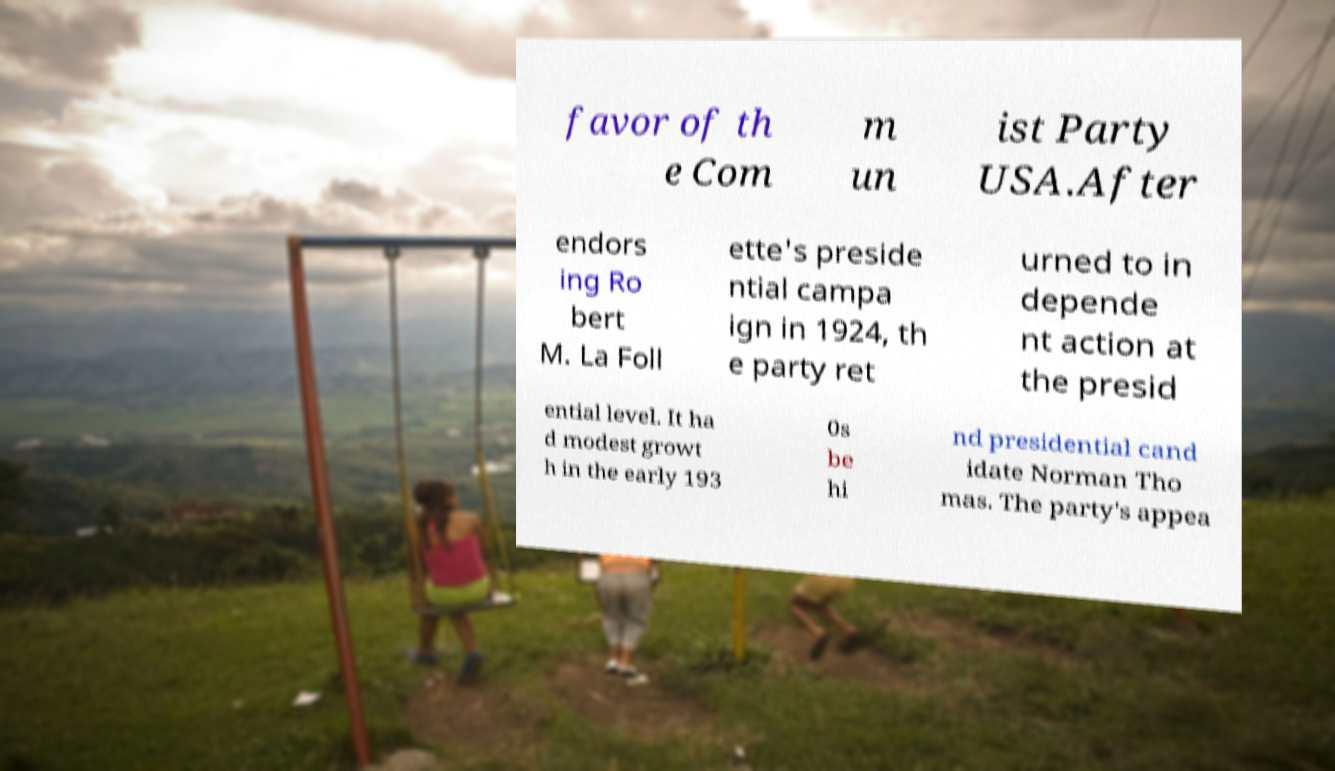Can you read and provide the text displayed in the image?This photo seems to have some interesting text. Can you extract and type it out for me? favor of th e Com m un ist Party USA.After endors ing Ro bert M. La Foll ette's preside ntial campa ign in 1924, th e party ret urned to in depende nt action at the presid ential level. It ha d modest growt h in the early 193 0s be hi nd presidential cand idate Norman Tho mas. The party's appea 